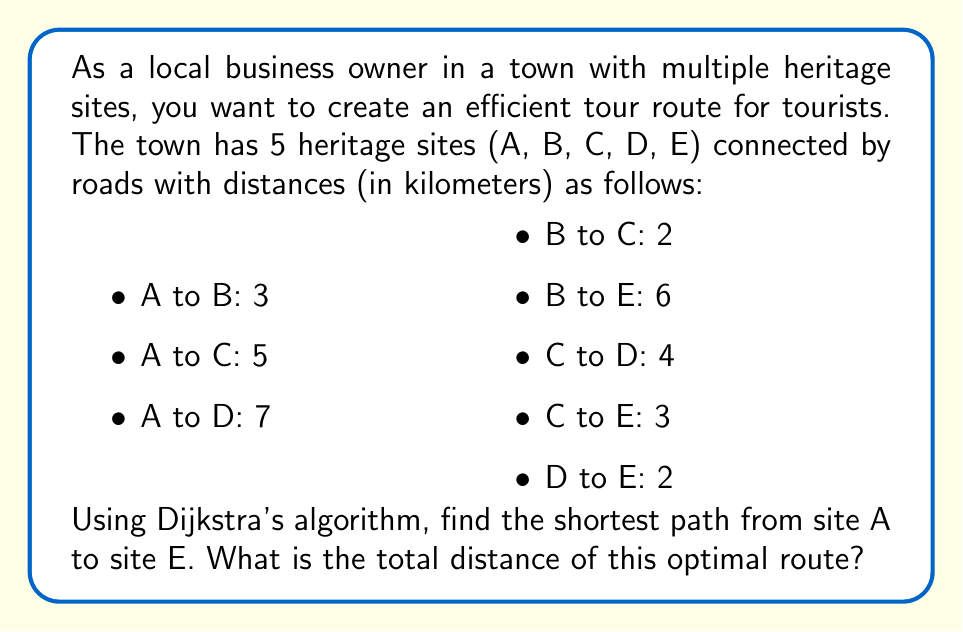Solve this math problem. To solve this problem, we'll use Dijkstra's algorithm to find the shortest path from site A to site E. Let's follow the steps:

1. Initialize:
   - Set distance to A as 0, and all other distances as infinity.
   - Set all nodes as unvisited.
   - Set A as the current node.

2. For the current node, consider all unvisited neighbors and calculate their tentative distances.
   - From A: B(3), C(5), D(7)

3. Mark A as visited. Set B as the current node (smallest tentative distance).

4. Update distances:
   - From B: C(3+2=5), E(3+6=9)

5. Mark B as visited. Set C as the current node.

6. Update distances:
   - From C: D(5+4=9), E(5+3=8)

7. Mark C as visited. Set E as the current node.

8. All nodes connected to E are visited, so the algorithm ends.

The shortest path from A to E is A → C → E.

To calculate the total distance:
$$ \text{Total distance} = d_{AC} + d_{CE} = 5 + 3 = 8 \text{ km} $$

Where $d_{AC}$ is the distance from A to C, and $d_{CE}$ is the distance from C to E.
Answer: The shortest path from site A to site E is 8 km. 